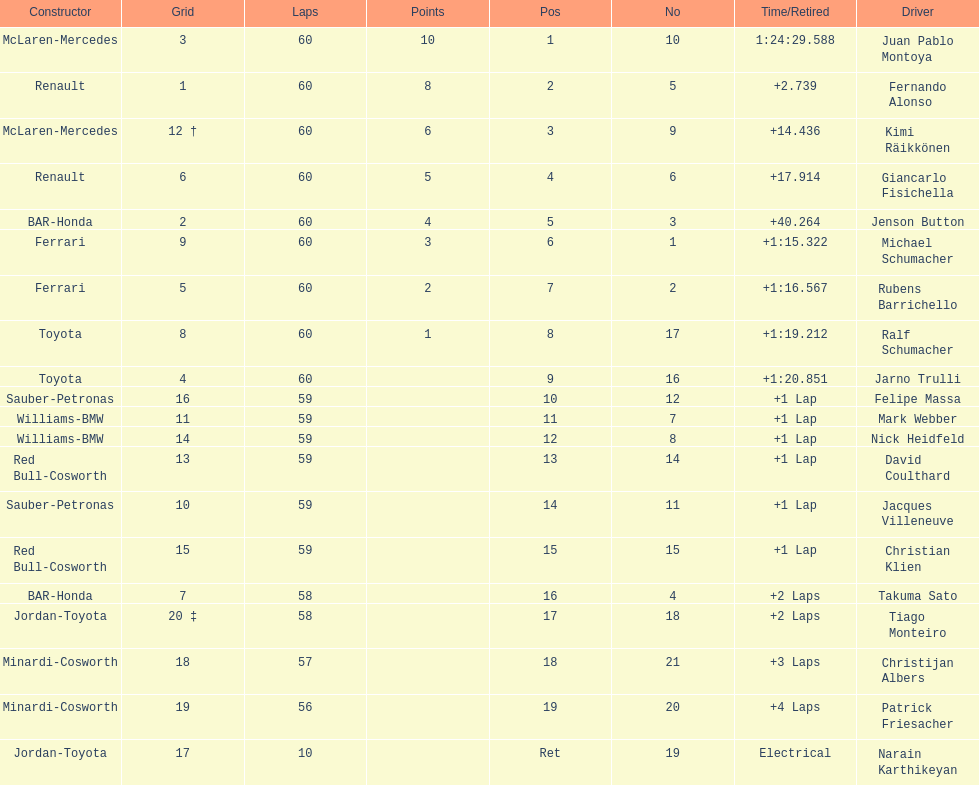Is there a points difference between the 9th position and 19th position on the list? No. 